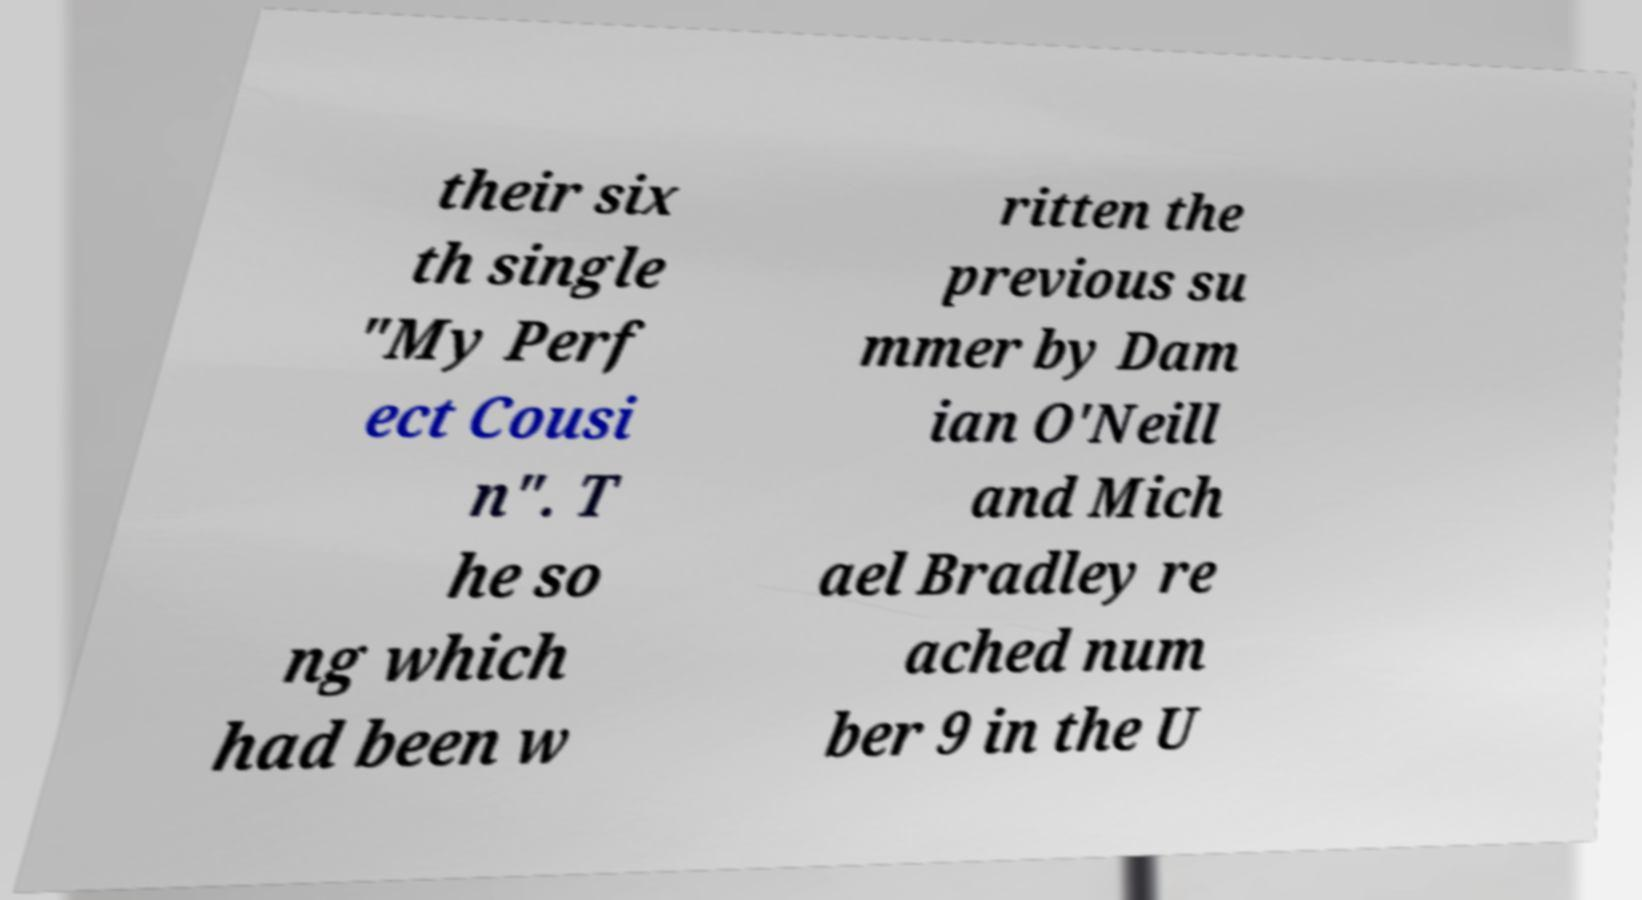I need the written content from this picture converted into text. Can you do that? their six th single "My Perf ect Cousi n". T he so ng which had been w ritten the previous su mmer by Dam ian O'Neill and Mich ael Bradley re ached num ber 9 in the U 